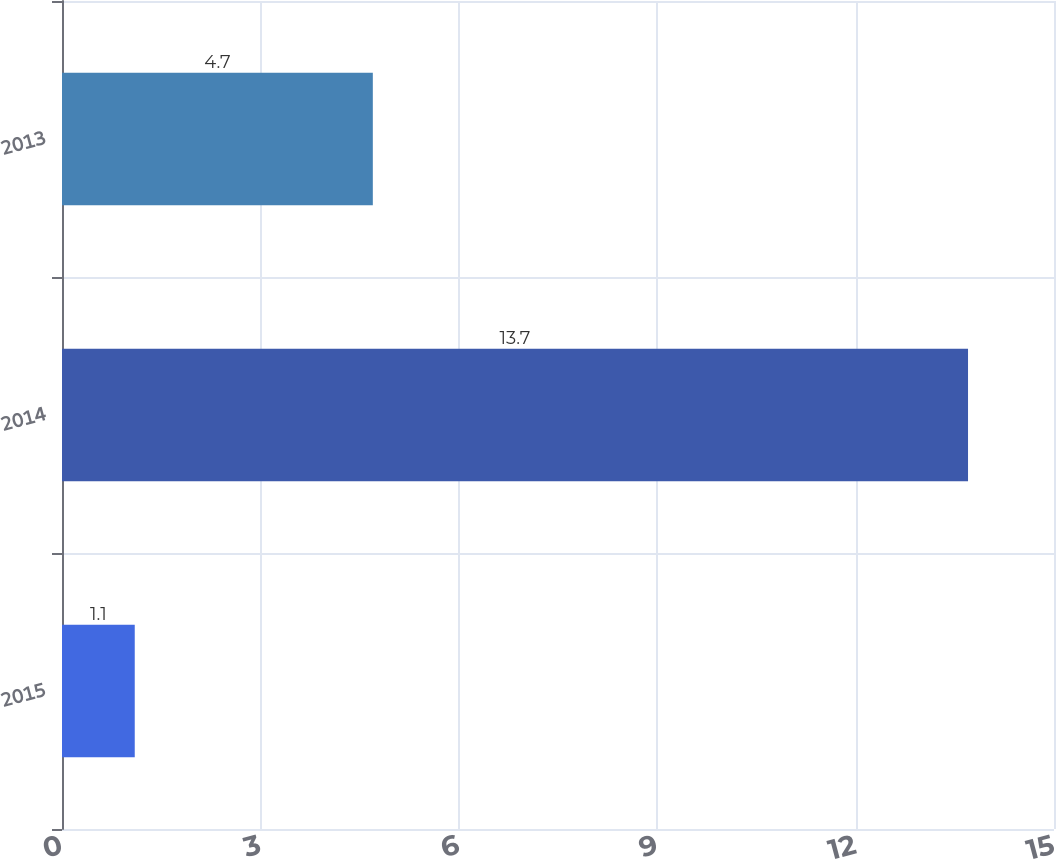Convert chart to OTSL. <chart><loc_0><loc_0><loc_500><loc_500><bar_chart><fcel>2015<fcel>2014<fcel>2013<nl><fcel>1.1<fcel>13.7<fcel>4.7<nl></chart> 